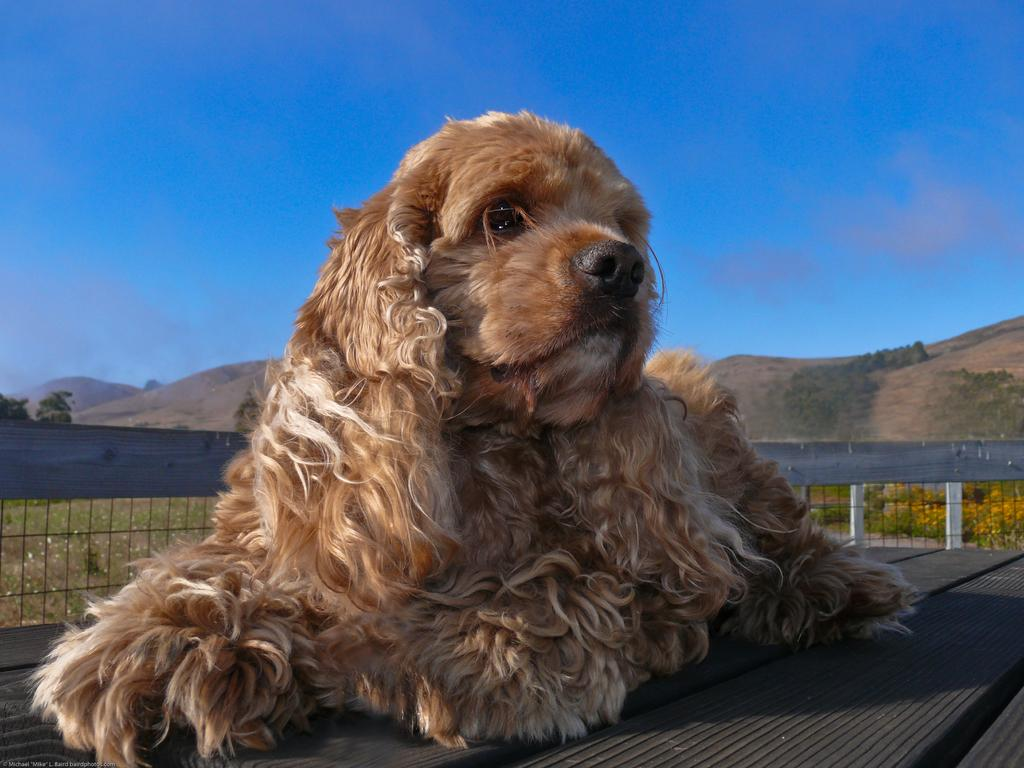What animal can be seen on a wooden surface in the image? There is a dog on a wooden surface in the image. What type of barrier is present in the image? There is fencing in the image. What type of vegetation is present in the image? Plants, flowers, and trees are present in the image. What type of landscape feature is visible in the image? Mountains are visible in the image. What part of the natural environment is visible in the image? The sky is visible in the image. What type of glass is being used to give advice to the dog in the image? There is no glass or advice-giving in the image; it features a dog on a wooden surface with various landscape features in the background. 